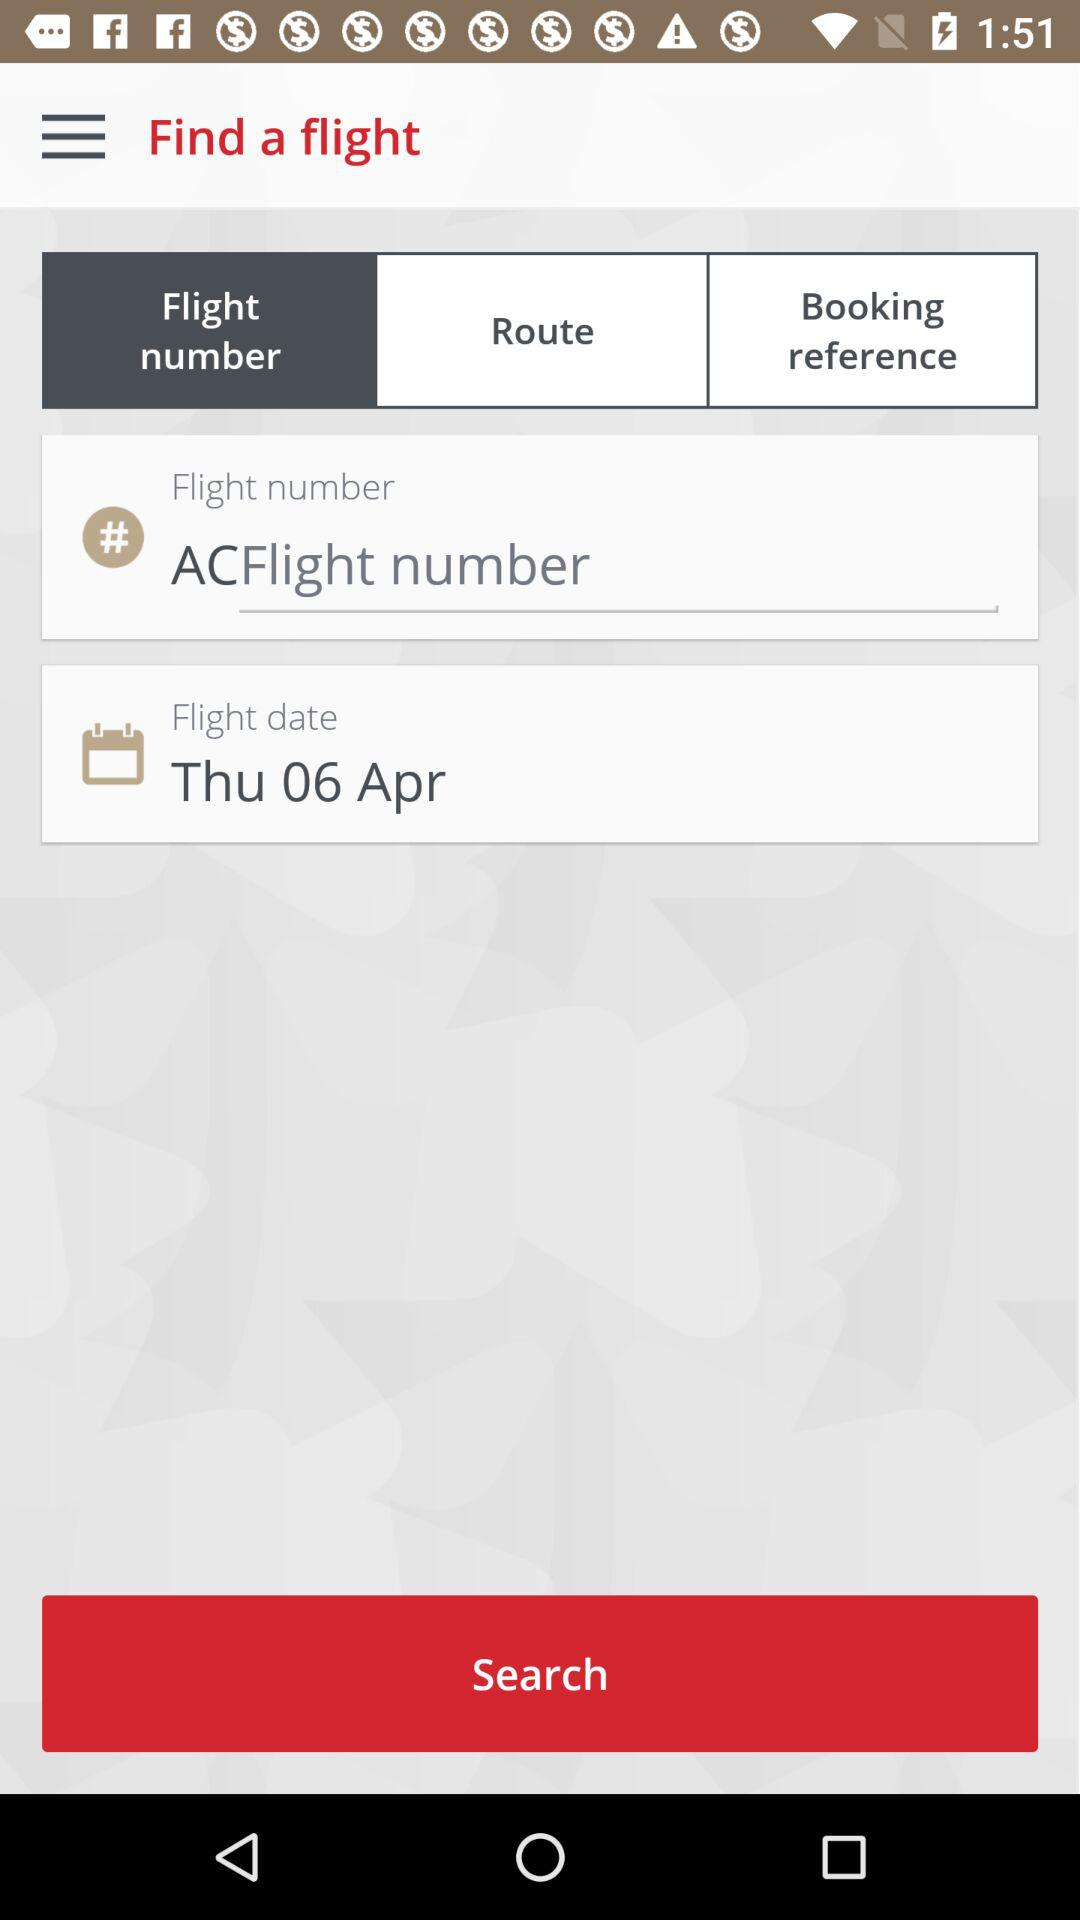Is this interface user-friendly for someone not familiar with flight details and terminologies? The interface shown in the image seems to have a clean layout, with clearly labeled fields that indicate what information is required. The presence of a flight number field suggests it caters to more experienced travelers, but the other fields like 'Route' and 'Flight date' should be straightforward for most users. Additional details like tooltips or a help button could potentially enhance its user-friendliness. 